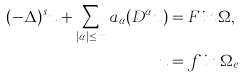Convert formula to latex. <formula><loc_0><loc_0><loc_500><loc_500>( - \Delta ) ^ { s } u + \sum _ { | \alpha | \leq m } a _ { \alpha } ( D ^ { \alpha } u ) & = F i n \, \Omega , \\ u & = f i n \, \Omega _ { e }</formula> 